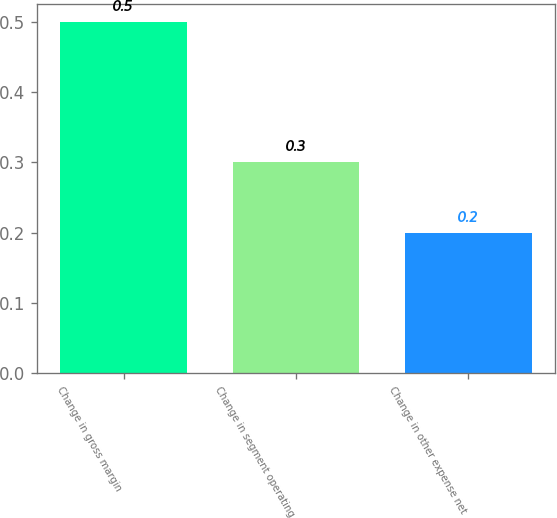Convert chart. <chart><loc_0><loc_0><loc_500><loc_500><bar_chart><fcel>Change in gross margin<fcel>Change in segment operating<fcel>Change in other expense net<nl><fcel>0.5<fcel>0.3<fcel>0.2<nl></chart> 